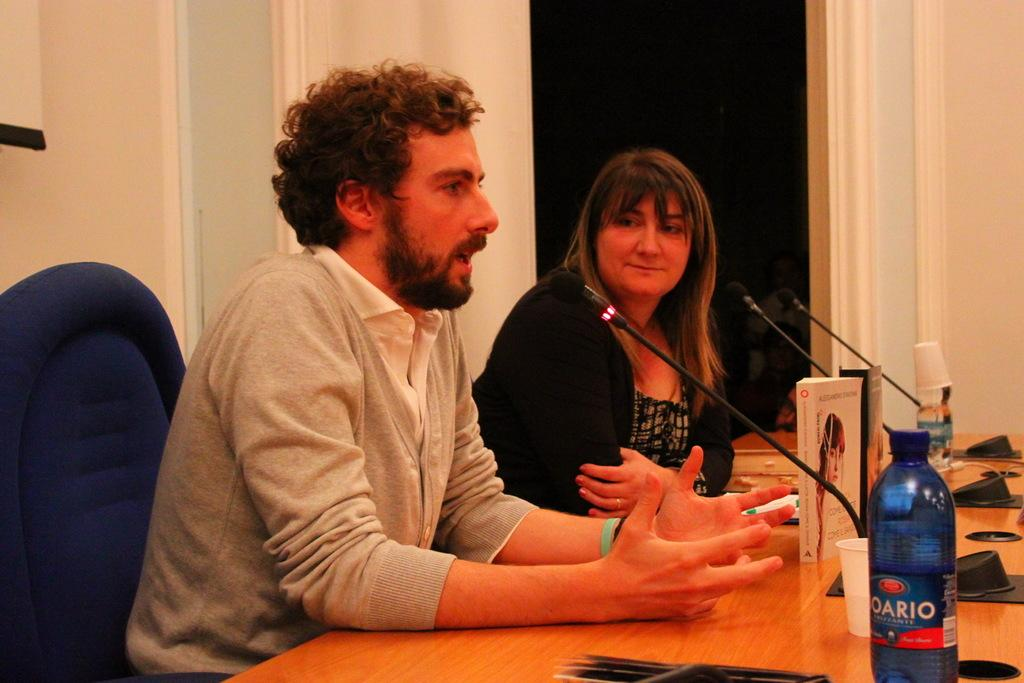How many people are in the image? There are two people in the image, a man and a woman. What are the man and woman doing in the image? Both the man and woman are sitting on chairs. What is in front of the man and woman? There is a table in front of them. What items can be seen on the table? There are mice, bottles, cups, and books on the table. What is visible in the background of the image? There is a wall in the background of the image. What type of dog is sitting next to the queen in the image? There is no queen or dog present in the image. Where is the pocket located on the man in the image? There is no mention of a pocket on the man in the image. 